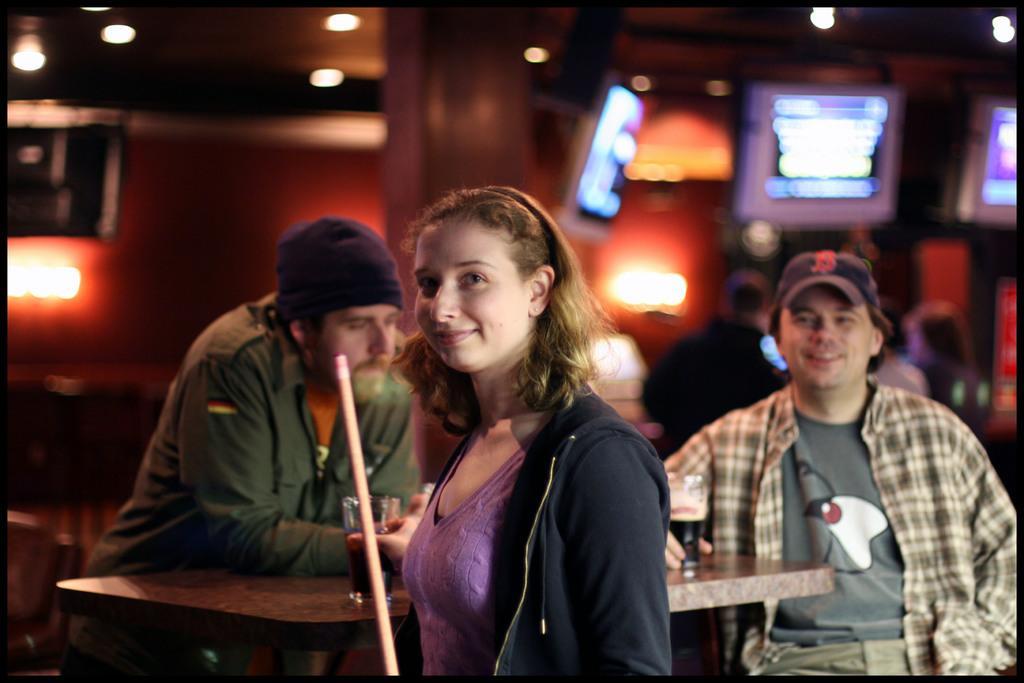How would you summarize this image in a sentence or two? In this picture we can see two men and a woman here, they are holding glasses of drinks, there is a table here, we can see a stick here, in the background there are some lights and screens. 